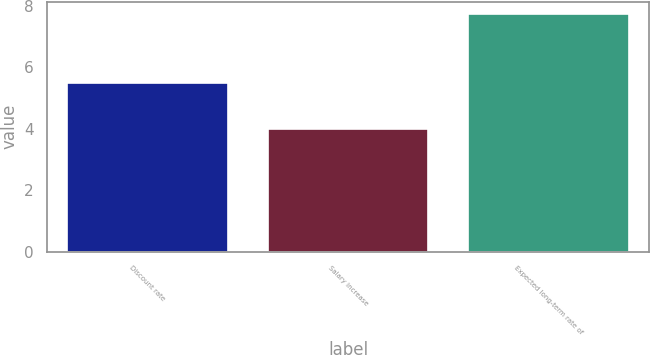Convert chart. <chart><loc_0><loc_0><loc_500><loc_500><bar_chart><fcel>Discount rate<fcel>Salary increase<fcel>Expected long-term rate of<nl><fcel>5.5<fcel>4<fcel>7.75<nl></chart> 